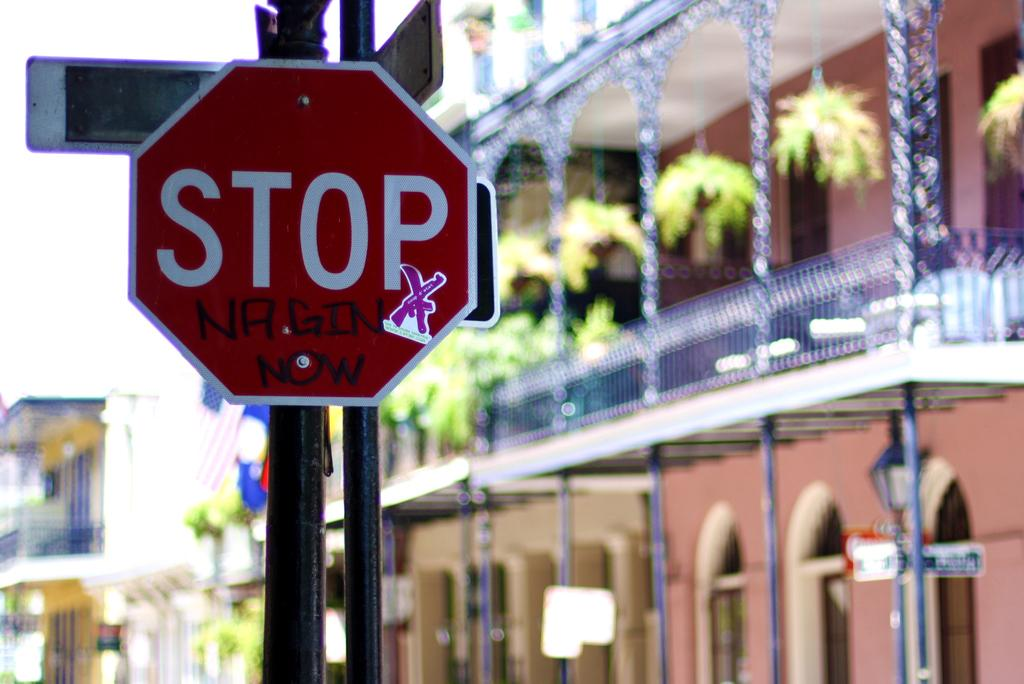Provide a one-sentence caption for the provided image. A stop sign with graffiti saying NRG GIN now and a purple ribbon sticker on it. 